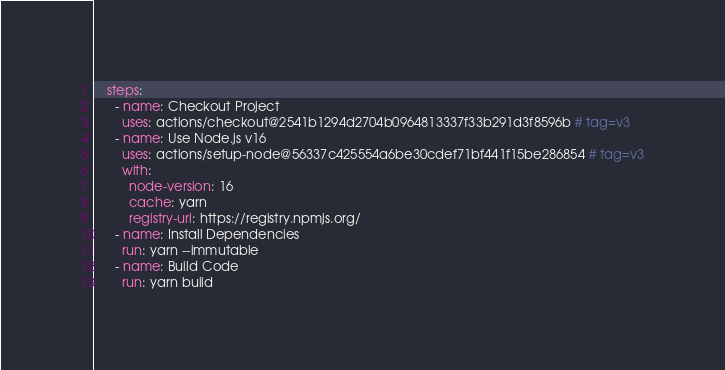Convert code to text. <code><loc_0><loc_0><loc_500><loc_500><_YAML_>    steps:
      - name: Checkout Project
        uses: actions/checkout@2541b1294d2704b0964813337f33b291d3f8596b # tag=v3
      - name: Use Node.js v16
        uses: actions/setup-node@56337c425554a6be30cdef71bf441f15be286854 # tag=v3
        with:
          node-version: 16
          cache: yarn
          registry-url: https://registry.npmjs.org/
      - name: Install Dependencies
        run: yarn --immutable
      - name: Build Code
        run: yarn build
</code> 